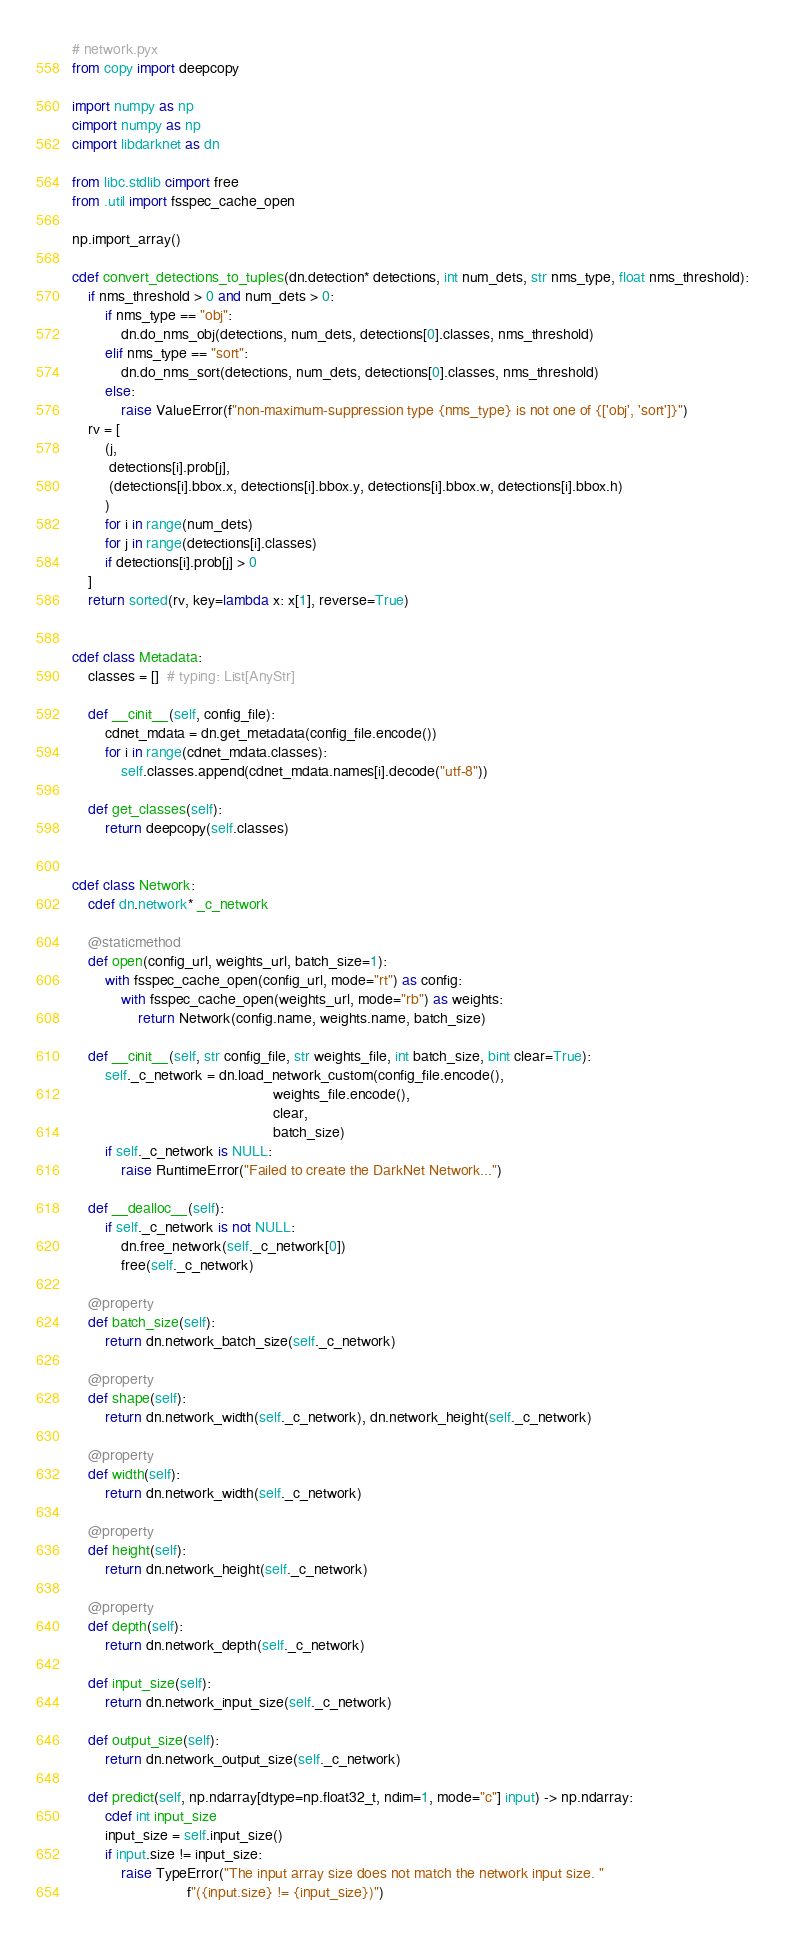<code> <loc_0><loc_0><loc_500><loc_500><_Cython_># network.pyx
from copy import deepcopy

import numpy as np
cimport numpy as np
cimport libdarknet as dn

from libc.stdlib cimport free
from .util import fsspec_cache_open

np.import_array()

cdef convert_detections_to_tuples(dn.detection* detections, int num_dets, str nms_type, float nms_threshold):
    if nms_threshold > 0 and num_dets > 0:
        if nms_type == "obj":
            dn.do_nms_obj(detections, num_dets, detections[0].classes, nms_threshold)
        elif nms_type == "sort":
            dn.do_nms_sort(detections, num_dets, detections[0].classes, nms_threshold)
        else:
            raise ValueError(f"non-maximum-suppression type {nms_type} is not one of {['obj', 'sort']}")
    rv = [
        (j,
         detections[i].prob[j],
         (detections[i].bbox.x, detections[i].bbox.y, detections[i].bbox.w, detections[i].bbox.h)
        )
        for i in range(num_dets)
        for j in range(detections[i].classes)
        if detections[i].prob[j] > 0
    ]
    return sorted(rv, key=lambda x: x[1], reverse=True)


cdef class Metadata:
    classes = []  # typing: List[AnyStr]

    def __cinit__(self, config_file):
        cdnet_mdata = dn.get_metadata(config_file.encode())
        for i in range(cdnet_mdata.classes):
            self.classes.append(cdnet_mdata.names[i].decode("utf-8"))

    def get_classes(self):
        return deepcopy(self.classes)


cdef class Network:
    cdef dn.network* _c_network

    @staticmethod
    def open(config_url, weights_url, batch_size=1):
        with fsspec_cache_open(config_url, mode="rt") as config:
            with fsspec_cache_open(weights_url, mode="rb") as weights:
                return Network(config.name, weights.name, batch_size)

    def __cinit__(self, str config_file, str weights_file, int batch_size, bint clear=True):
        self._c_network = dn.load_network_custom(config_file.encode(),
                                                 weights_file.encode(),
                                                 clear,
                                                 batch_size)
        if self._c_network is NULL:
            raise RuntimeError("Failed to create the DarkNet Network...")

    def __dealloc__(self):
        if self._c_network is not NULL:
            dn.free_network(self._c_network[0])
            free(self._c_network)

    @property
    def batch_size(self):
        return dn.network_batch_size(self._c_network)

    @property
    def shape(self):
        return dn.network_width(self._c_network), dn.network_height(self._c_network)

    @property
    def width(self):
        return dn.network_width(self._c_network)

    @property
    def height(self):
        return dn.network_height(self._c_network)

    @property
    def depth(self):
        return dn.network_depth(self._c_network)

    def input_size(self):
        return dn.network_input_size(self._c_network)

    def output_size(self):
        return dn.network_output_size(self._c_network)

    def predict(self, np.ndarray[dtype=np.float32_t, ndim=1, mode="c"] input) -> np.ndarray:
        cdef int input_size
        input_size = self.input_size()
        if input.size != input_size:
            raise TypeError("The input array size does not match the network input size. "
                            f"({input.size} != {input_size})")
</code> 